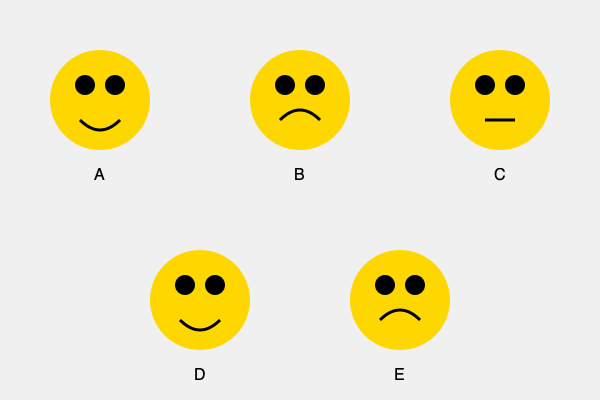Based on the illustrated facial expressions of children A through E, which child is most likely experiencing anxiety or fear? Explain your reasoning and discuss how a parent can appropriately respond to support the child's emotional development. To answer this question, we need to analyze each child's facial expression and body language:

1. Child A: Shows a broad smile, indicating happiness or excitement.
2. Child B: Displays a slight frown or concerned expression, potentially indicating worry or mild distress.
3. Child C: Has a neutral expression, showing neither positive nor negative emotions.
4. Child D: Exhibits a wide smile, similar to Child A, suggesting joy or enthusiasm.
5. Child E: Shows a pronounced frown with downturned corners of the mouth, indicating sadness or distress.

Among these, Child B is most likely experiencing anxiety or fear. The slight frown and concerned expression are typical indicators of worry or mild distress in children. This contrasts with the more obvious distress shown by Child E (sadness) and the positive emotions displayed by Children A and D.

To support Child B's emotional development, a parent can:

1. Acknowledge the emotion: "I notice you look worried. Is something bothering you?"
2. Validate the feeling: "It's okay to feel anxious sometimes. Everyone does."
3. Encourage expression: "Can you tell me more about what's making you feel this way?"
4. Offer comfort: Provide physical reassurance if the child is receptive, such as a hug or holding hands.
5. Problem-solve together: "Let's think about what we can do to help you feel better."
6. Teach coping strategies: Introduce simple techniques like deep breathing or counting to ten.
7. Model emotional regulation: Demonstrate how to handle anxiety calmly and positively.
8. Follow up: Check in with the child later to see if their emotional state has improved.

By responding supportively to Child B's anxiety, the parent helps the child develop emotional intelligence, learn to identify and express emotions, and build coping mechanisms for future challenges.
Answer: Child B; respond with acknowledgment, validation, encouragement of expression, comfort, problem-solving, teaching coping strategies, modeling regulation, and follow-up. 